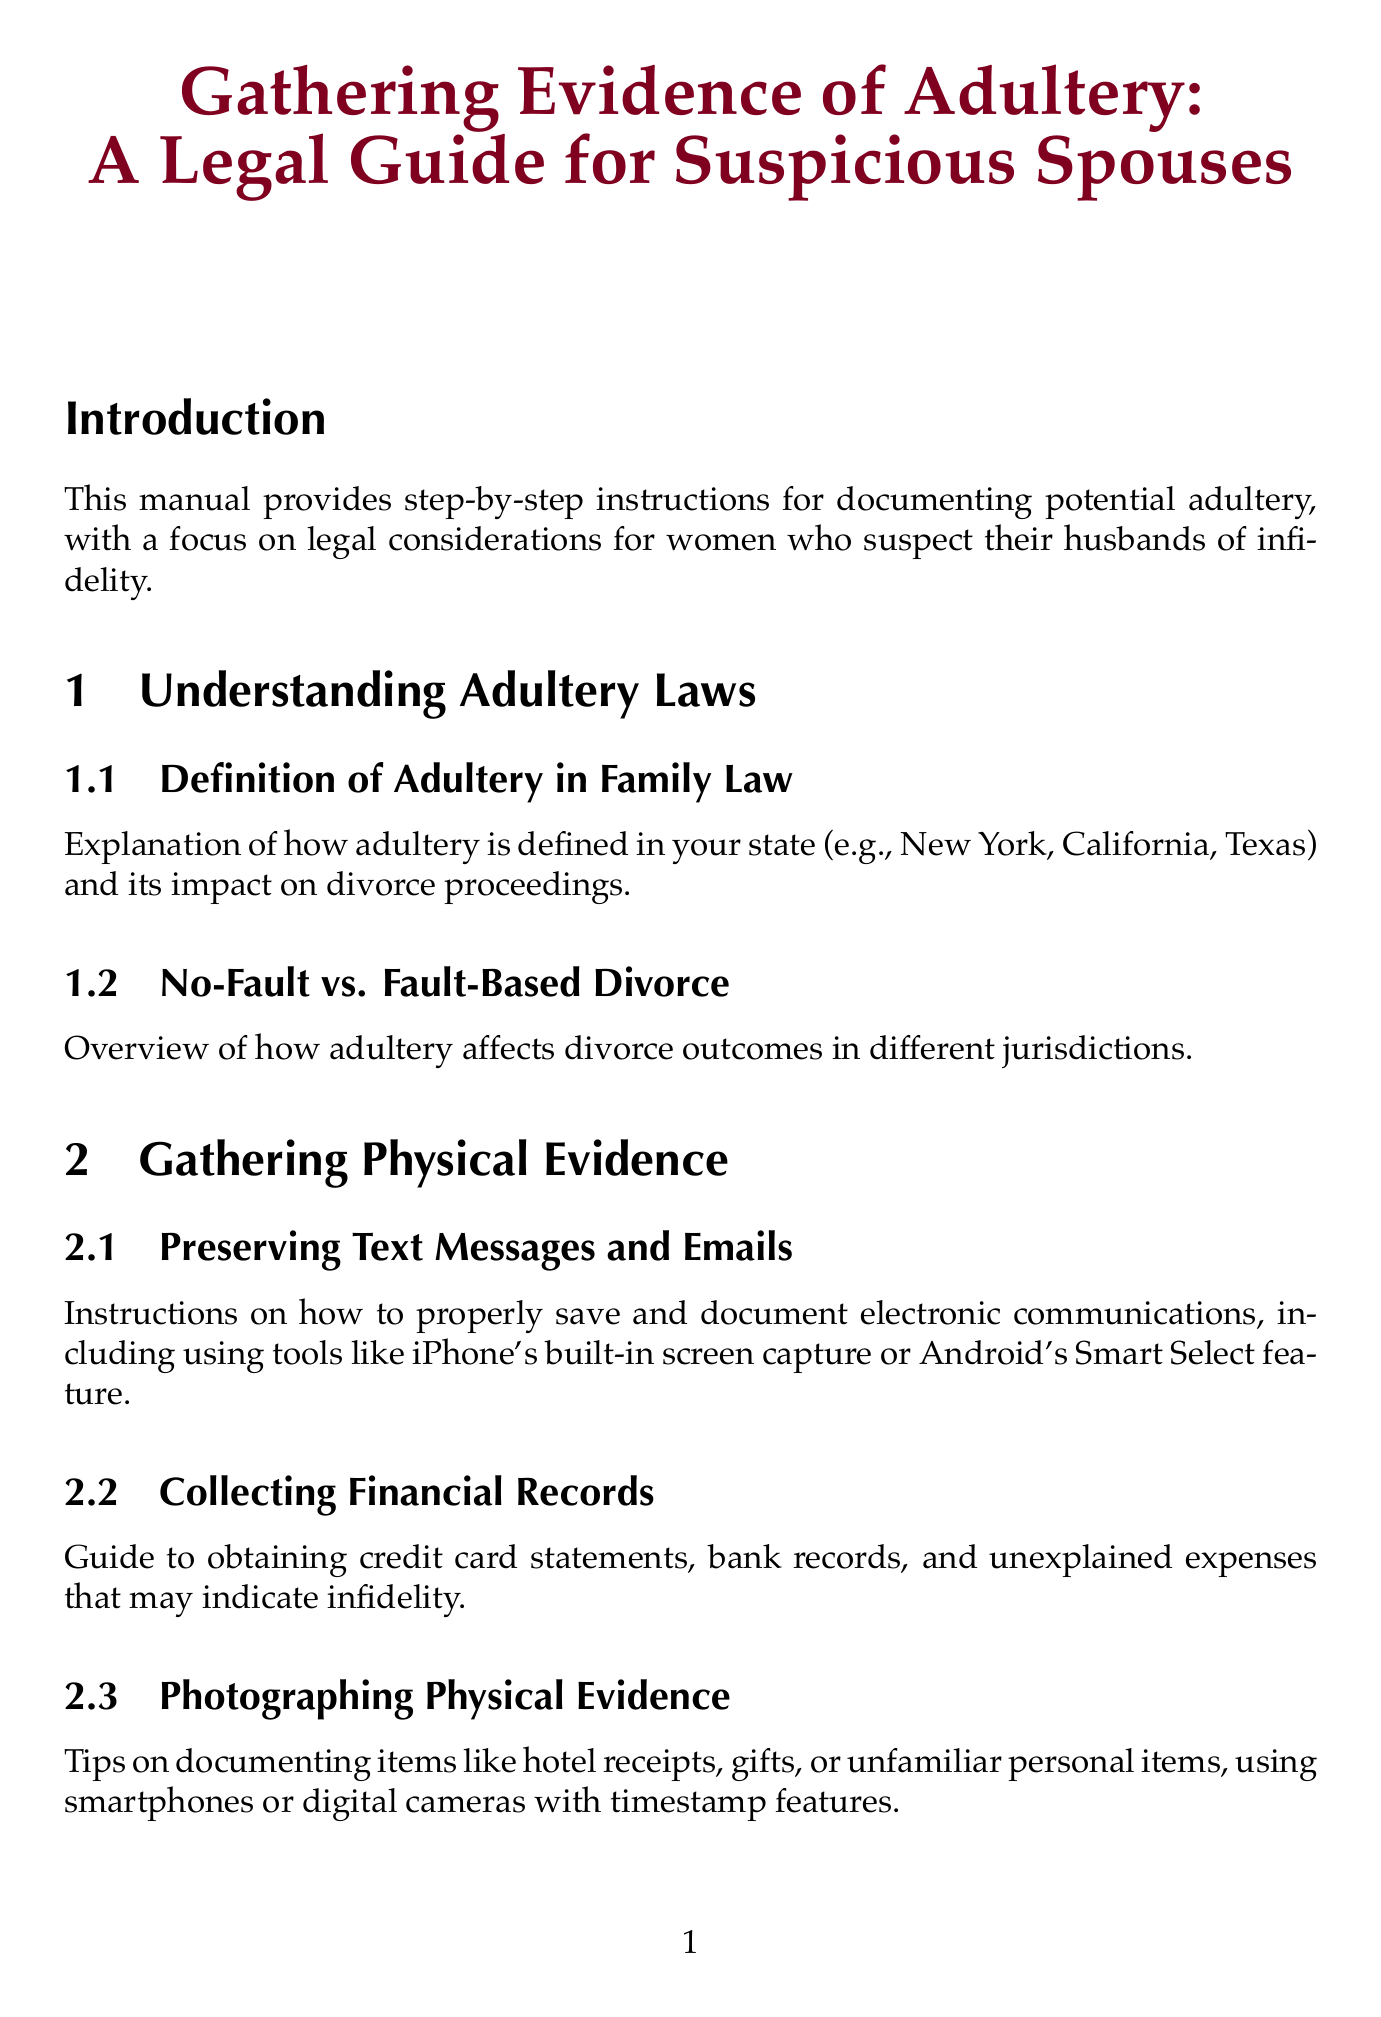What is the title of the manual? The title of the manual is stated clearly at the beginning of the document.
Answer: Gathering Evidence of Adultery: A Legal Guide for Suspicious Spouses What does the introduction emphasize? The introduction highlights the purpose of the manual and its focus on a specific audience.
Answer: Legal considerations for women who suspect their husbands of infidelity What is one method for gathering physical evidence mentioned? The document lists various methods in the chapter on gathering physical evidence, and one specific method is chosen as an example.
Answer: Preserving Text Messages and Emails What is the guide for selecting a divorce attorney? The manual provides a specific guide in the last section, aiming to help with the selection process.
Answer: Choosing an experienced family law attorney What do witness statements need to be for legal admissibility? The document states requirements for how to collect evidence in a legally acceptable manner.
Answer: Notarized How many chapters are there in the manual? The count of chapters is a measurable detail that can be found in the structure of the document.
Answer: Seven What type of law does the document overview? The manual focuses on a specific area of law related to personal relationships and legal consequences.
Answer: Family Law What is an example of digital surveillance mentioned? The document outlines several digital methods, and one is specified for clarity.
Answer: Social Media Monitoring What does the conclusion advise prioritizing? The last section addresses important personal considerations while gathering evidence.
Answer: Emotional well-being and safety 